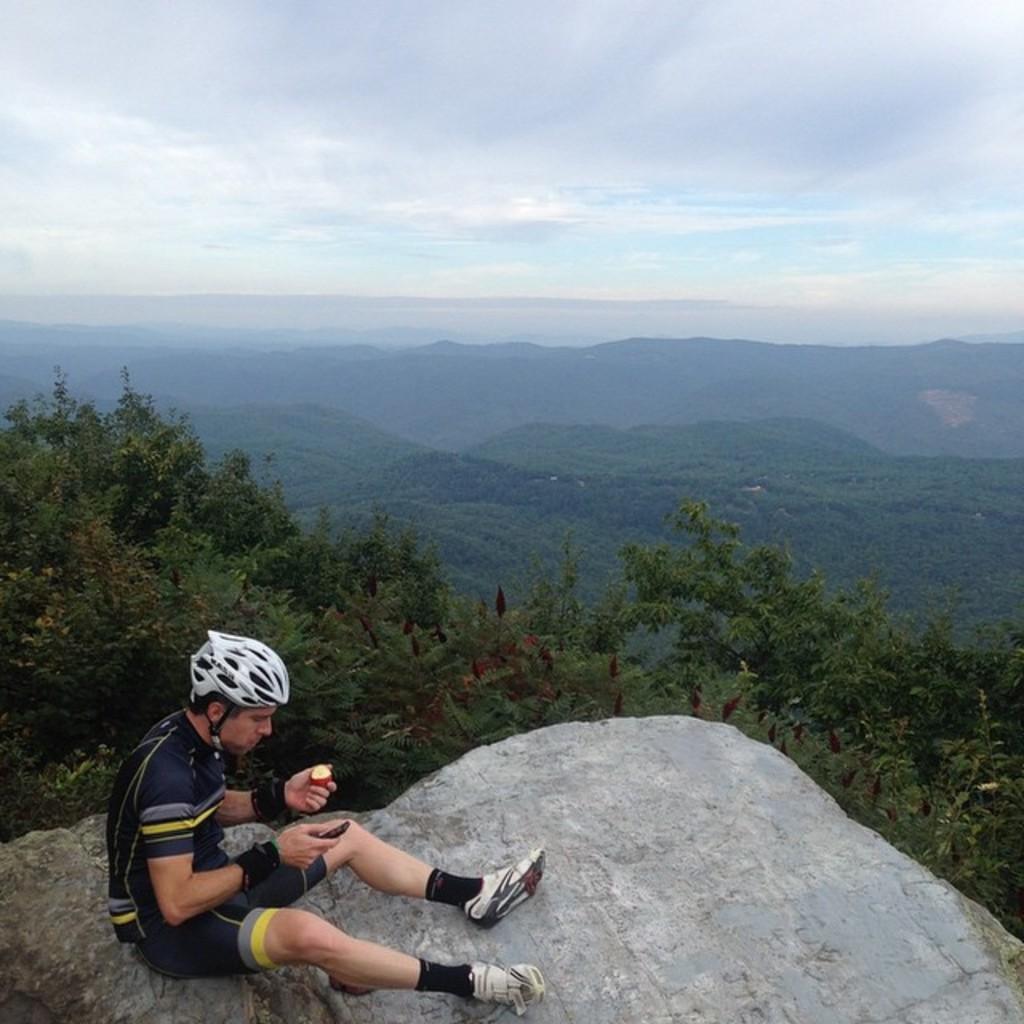How would you summarize this image in a sentence or two? In this image, we can see a person on the rock. This person is wearing clothes and helmet. There are some trees and hills in the middle of the image. In the background of the image, there is a sky. 